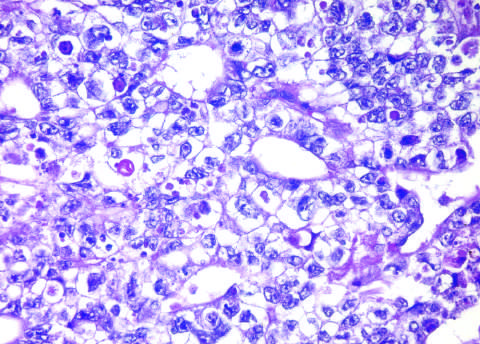what is hemorrhagic?
Answer the question using a single word or phrase. The tumor 